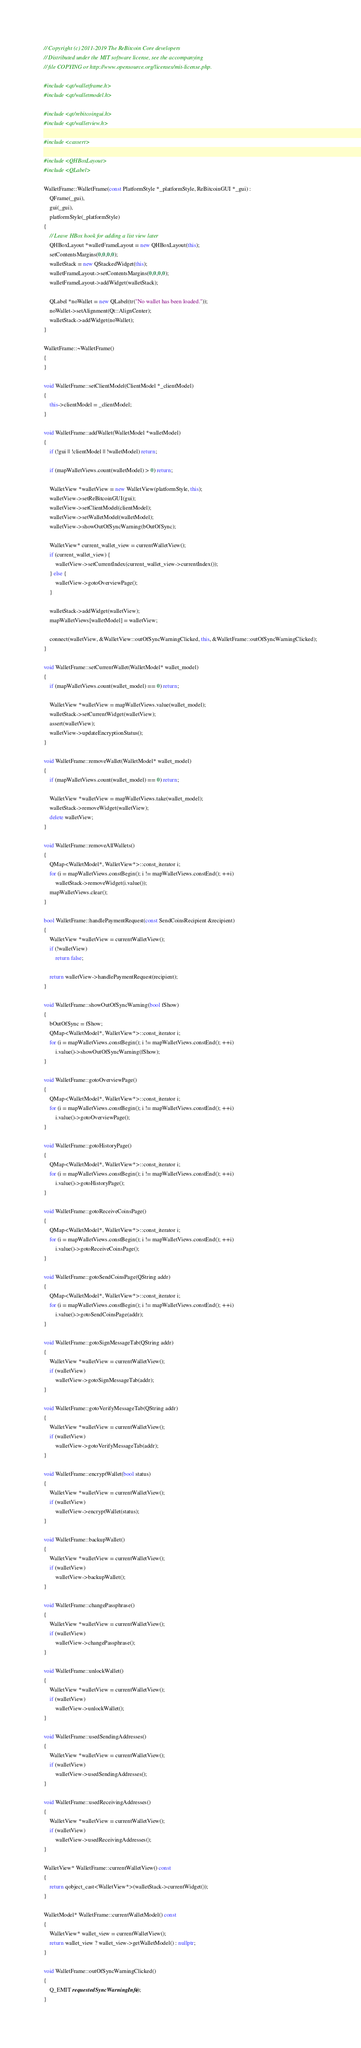Convert code to text. <code><loc_0><loc_0><loc_500><loc_500><_C++_>// Copyright (c) 2011-2019 The ReBitcoin Core developers
// Distributed under the MIT software license, see the accompanying
// file COPYING or http://www.opensource.org/licenses/mit-license.php.

#include <qt/walletframe.h>
#include <qt/walletmodel.h>

#include <qt/rebitcoingui.h>
#include <qt/walletview.h>

#include <cassert>

#include <QHBoxLayout>
#include <QLabel>

WalletFrame::WalletFrame(const PlatformStyle *_platformStyle, ReBitcoinGUI *_gui) :
    QFrame(_gui),
    gui(_gui),
    platformStyle(_platformStyle)
{
    // Leave HBox hook for adding a list view later
    QHBoxLayout *walletFrameLayout = new QHBoxLayout(this);
    setContentsMargins(0,0,0,0);
    walletStack = new QStackedWidget(this);
    walletFrameLayout->setContentsMargins(0,0,0,0);
    walletFrameLayout->addWidget(walletStack);

    QLabel *noWallet = new QLabel(tr("No wallet has been loaded."));
    noWallet->setAlignment(Qt::AlignCenter);
    walletStack->addWidget(noWallet);
}

WalletFrame::~WalletFrame()
{
}

void WalletFrame::setClientModel(ClientModel *_clientModel)
{
    this->clientModel = _clientModel;
}

void WalletFrame::addWallet(WalletModel *walletModel)
{
    if (!gui || !clientModel || !walletModel) return;

    if (mapWalletViews.count(walletModel) > 0) return;

    WalletView *walletView = new WalletView(platformStyle, this);
    walletView->setReBitcoinGUI(gui);
    walletView->setClientModel(clientModel);
    walletView->setWalletModel(walletModel);
    walletView->showOutOfSyncWarning(bOutOfSync);

    WalletView* current_wallet_view = currentWalletView();
    if (current_wallet_view) {
        walletView->setCurrentIndex(current_wallet_view->currentIndex());
    } else {
        walletView->gotoOverviewPage();
    }

    walletStack->addWidget(walletView);
    mapWalletViews[walletModel] = walletView;

    connect(walletView, &WalletView::outOfSyncWarningClicked, this, &WalletFrame::outOfSyncWarningClicked);
}

void WalletFrame::setCurrentWallet(WalletModel* wallet_model)
{
    if (mapWalletViews.count(wallet_model) == 0) return;

    WalletView *walletView = mapWalletViews.value(wallet_model);
    walletStack->setCurrentWidget(walletView);
    assert(walletView);
    walletView->updateEncryptionStatus();
}

void WalletFrame::removeWallet(WalletModel* wallet_model)
{
    if (mapWalletViews.count(wallet_model) == 0) return;

    WalletView *walletView = mapWalletViews.take(wallet_model);
    walletStack->removeWidget(walletView);
    delete walletView;
}

void WalletFrame::removeAllWallets()
{
    QMap<WalletModel*, WalletView*>::const_iterator i;
    for (i = mapWalletViews.constBegin(); i != mapWalletViews.constEnd(); ++i)
        walletStack->removeWidget(i.value());
    mapWalletViews.clear();
}

bool WalletFrame::handlePaymentRequest(const SendCoinsRecipient &recipient)
{
    WalletView *walletView = currentWalletView();
    if (!walletView)
        return false;

    return walletView->handlePaymentRequest(recipient);
}

void WalletFrame::showOutOfSyncWarning(bool fShow)
{
    bOutOfSync = fShow;
    QMap<WalletModel*, WalletView*>::const_iterator i;
    for (i = mapWalletViews.constBegin(); i != mapWalletViews.constEnd(); ++i)
        i.value()->showOutOfSyncWarning(fShow);
}

void WalletFrame::gotoOverviewPage()
{
    QMap<WalletModel*, WalletView*>::const_iterator i;
    for (i = mapWalletViews.constBegin(); i != mapWalletViews.constEnd(); ++i)
        i.value()->gotoOverviewPage();
}

void WalletFrame::gotoHistoryPage()
{
    QMap<WalletModel*, WalletView*>::const_iterator i;
    for (i = mapWalletViews.constBegin(); i != mapWalletViews.constEnd(); ++i)
        i.value()->gotoHistoryPage();
}

void WalletFrame::gotoReceiveCoinsPage()
{
    QMap<WalletModel*, WalletView*>::const_iterator i;
    for (i = mapWalletViews.constBegin(); i != mapWalletViews.constEnd(); ++i)
        i.value()->gotoReceiveCoinsPage();
}

void WalletFrame::gotoSendCoinsPage(QString addr)
{
    QMap<WalletModel*, WalletView*>::const_iterator i;
    for (i = mapWalletViews.constBegin(); i != mapWalletViews.constEnd(); ++i)
        i.value()->gotoSendCoinsPage(addr);
}

void WalletFrame::gotoSignMessageTab(QString addr)
{
    WalletView *walletView = currentWalletView();
    if (walletView)
        walletView->gotoSignMessageTab(addr);
}

void WalletFrame::gotoVerifyMessageTab(QString addr)
{
    WalletView *walletView = currentWalletView();
    if (walletView)
        walletView->gotoVerifyMessageTab(addr);
}

void WalletFrame::encryptWallet(bool status)
{
    WalletView *walletView = currentWalletView();
    if (walletView)
        walletView->encryptWallet(status);
}

void WalletFrame::backupWallet()
{
    WalletView *walletView = currentWalletView();
    if (walletView)
        walletView->backupWallet();
}

void WalletFrame::changePassphrase()
{
    WalletView *walletView = currentWalletView();
    if (walletView)
        walletView->changePassphrase();
}

void WalletFrame::unlockWallet()
{
    WalletView *walletView = currentWalletView();
    if (walletView)
        walletView->unlockWallet();
}

void WalletFrame::usedSendingAddresses()
{
    WalletView *walletView = currentWalletView();
    if (walletView)
        walletView->usedSendingAddresses();
}

void WalletFrame::usedReceivingAddresses()
{
    WalletView *walletView = currentWalletView();
    if (walletView)
        walletView->usedReceivingAddresses();
}

WalletView* WalletFrame::currentWalletView() const
{
    return qobject_cast<WalletView*>(walletStack->currentWidget());
}

WalletModel* WalletFrame::currentWalletModel() const
{
    WalletView* wallet_view = currentWalletView();
    return wallet_view ? wallet_view->getWalletModel() : nullptr;
}

void WalletFrame::outOfSyncWarningClicked()
{
    Q_EMIT requestedSyncWarningInfo();
}
</code> 